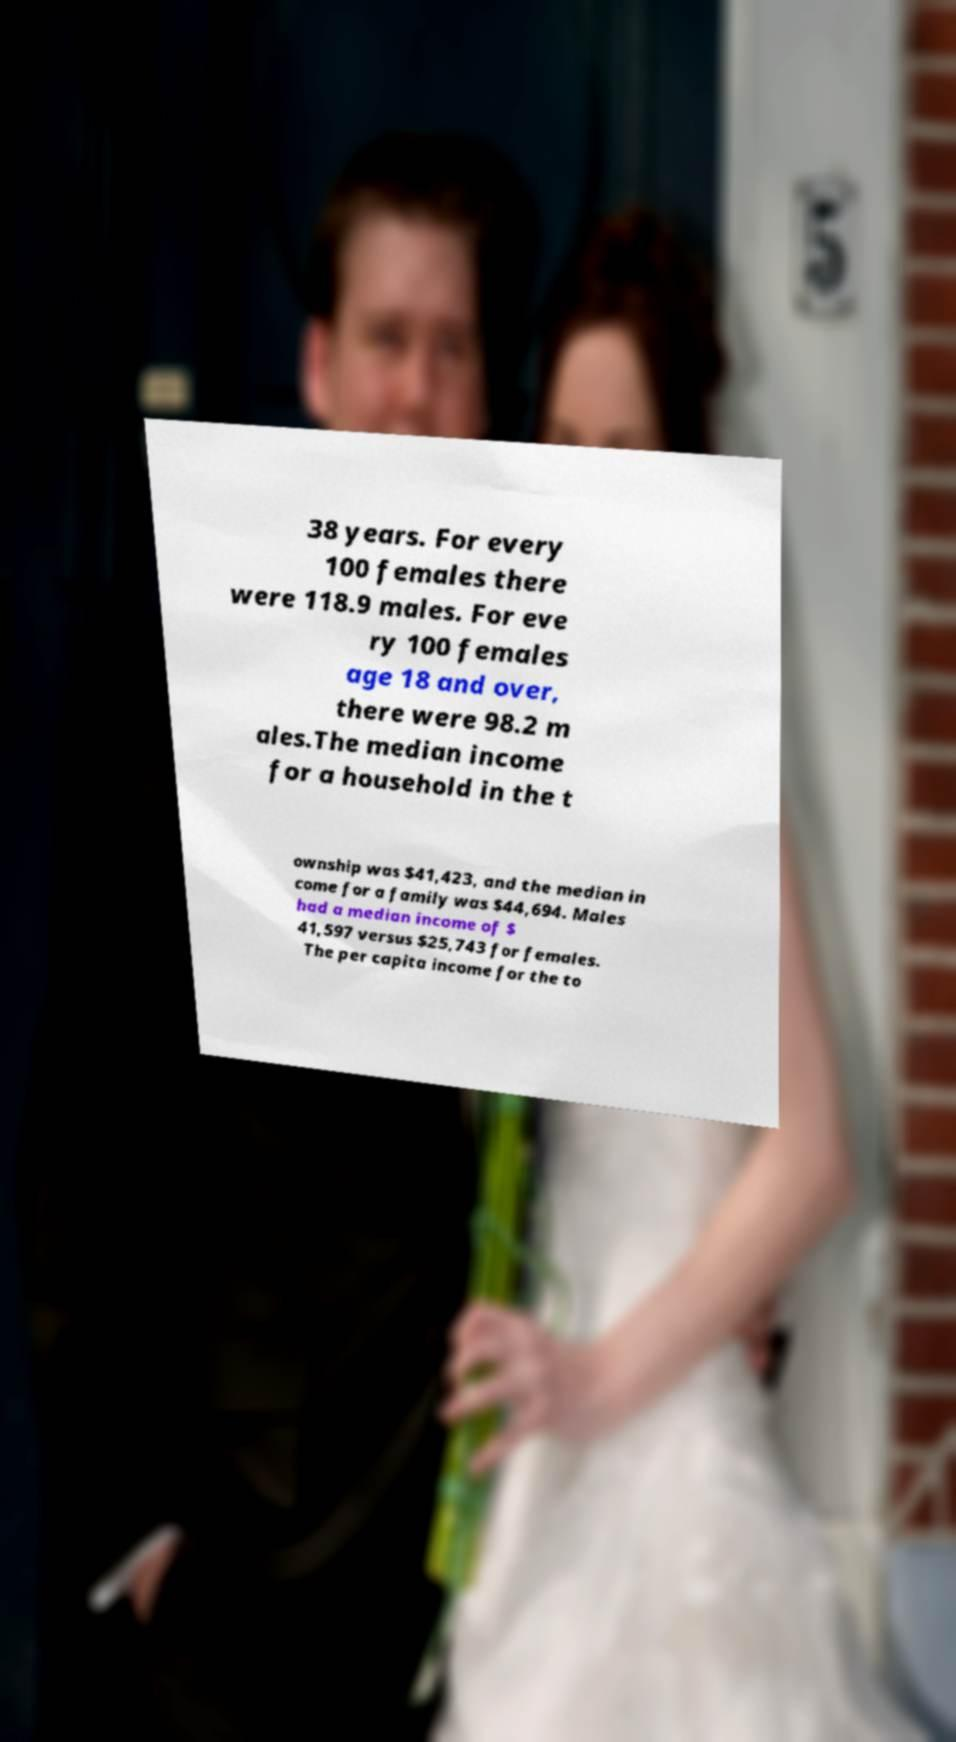I need the written content from this picture converted into text. Can you do that? 38 years. For every 100 females there were 118.9 males. For eve ry 100 females age 18 and over, there were 98.2 m ales.The median income for a household in the t ownship was $41,423, and the median in come for a family was $44,694. Males had a median income of $ 41,597 versus $25,743 for females. The per capita income for the to 